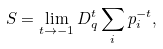Convert formula to latex. <formula><loc_0><loc_0><loc_500><loc_500>S = \lim _ { t \rightarrow - 1 } D _ { q } ^ { t } \sum _ { i } p _ { i } ^ { - t } ,</formula> 